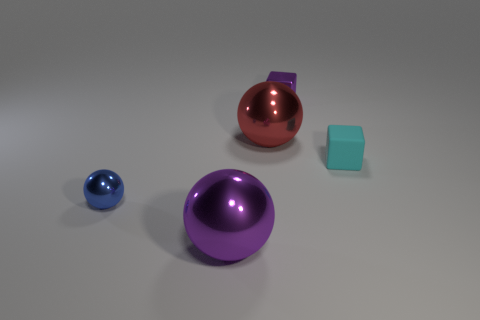Add 1 green metallic cubes. How many objects exist? 6 Subtract all yellow balls. Subtract all red cylinders. How many balls are left? 3 Subtract all blocks. How many objects are left? 3 Add 3 shiny balls. How many shiny balls are left? 6 Add 2 tiny blue objects. How many tiny blue objects exist? 3 Subtract 0 red cubes. How many objects are left? 5 Subtract all small purple cylinders. Subtract all big metallic things. How many objects are left? 3 